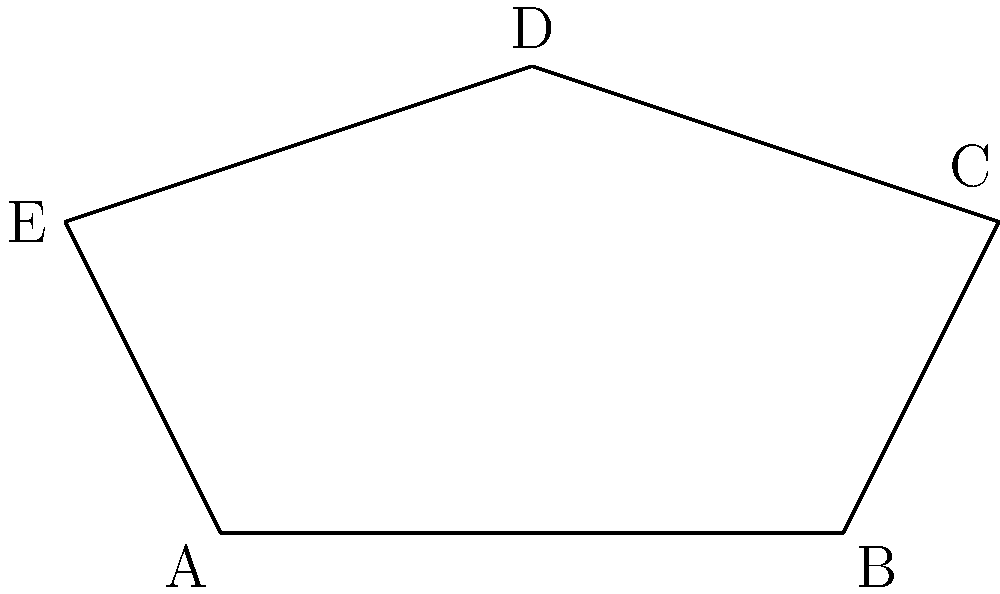In the galaxy far, far away, the shape of Imperial Star Destroyers inspired many to study geometry. If we simplify their shape to a pentagon, like the one shown above, what is the sum of all interior angles of this pentagon? Let's approach this step-by-step:

1) First, recall the formula for the sum of interior angles of a polygon with $n$ sides:

   $S = (n-2) \times 180°$

2) In this case, we have a pentagon, so $n = 5$

3) Let's substitute this into our formula:

   $S = (5-2) \times 180°$

4) Simplify:

   $S = 3 \times 180°$

5) Calculate:

   $S = 540°$

Therefore, the sum of all interior angles of a pentagon, just like our simplified Star Destroyer shape, is 540°.
Answer: 540° 